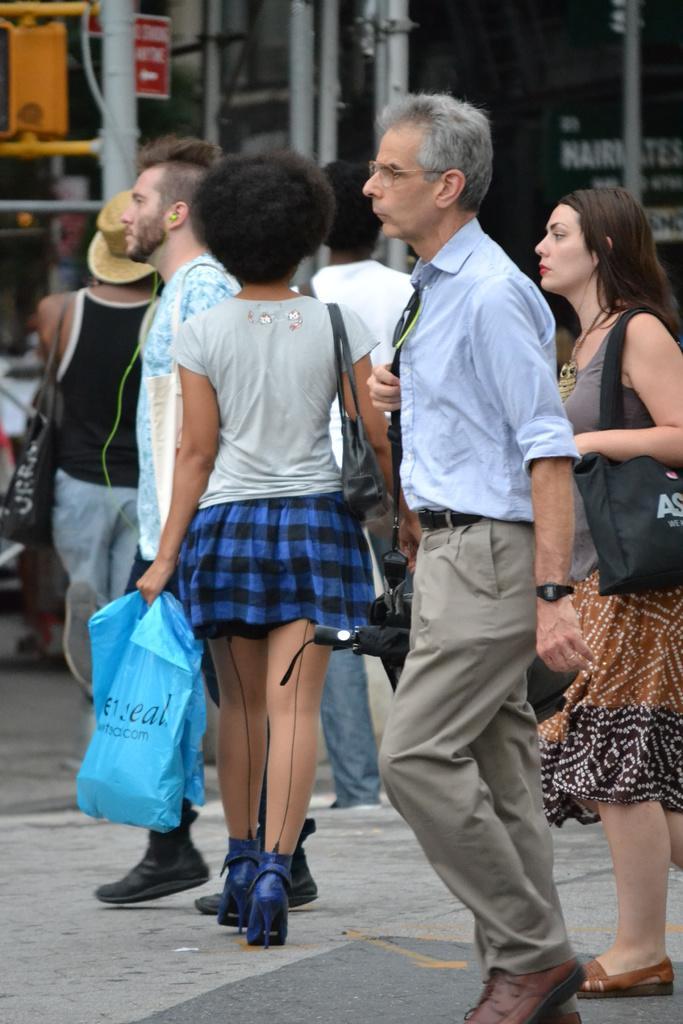Please provide a concise description of this image. This image is clicked on the road. There are many people walking on the road. They are wearing bags. Behind them there are poles and boards. In the top right there is text on the board. 